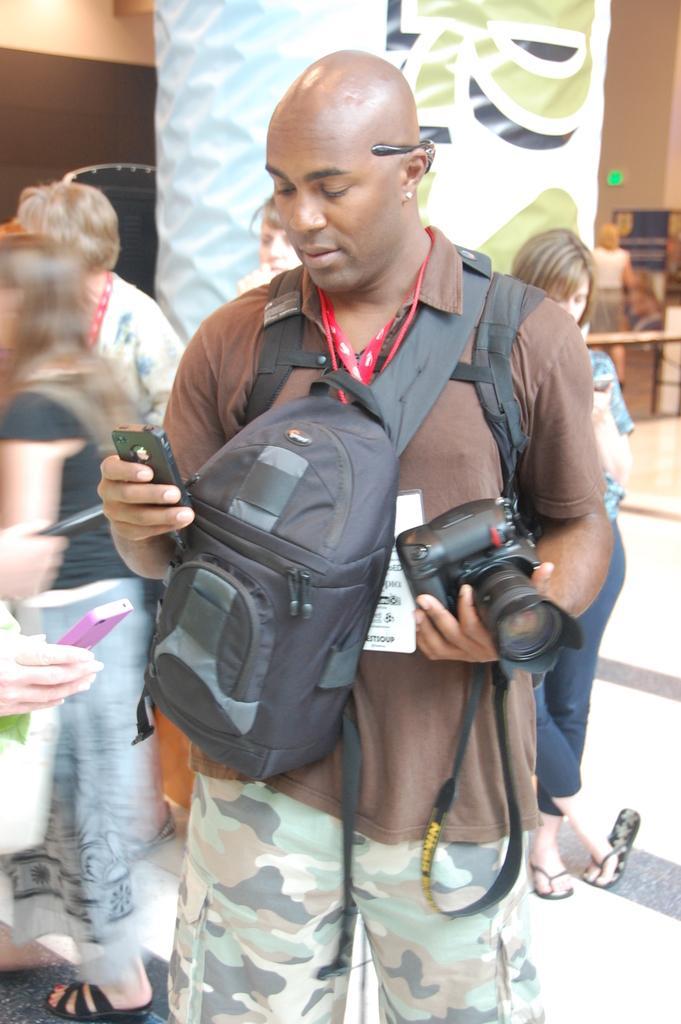Can you describe this image briefly? Here we can see a man with a camera in his hand and a mobile phone in another hand having bags on either side of him and behind him also we can see people standing and there is a banner behind him 